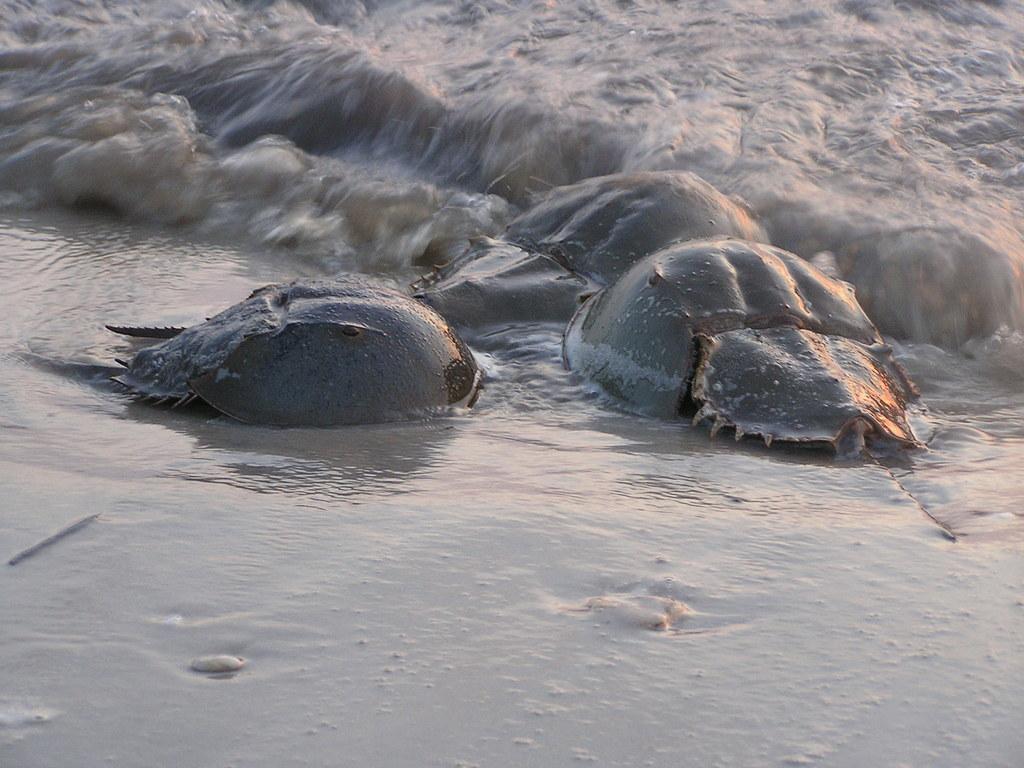Could you give a brief overview of what you see in this image? In this image we can see water animals on the sea shore. In the background of the image there is water. 